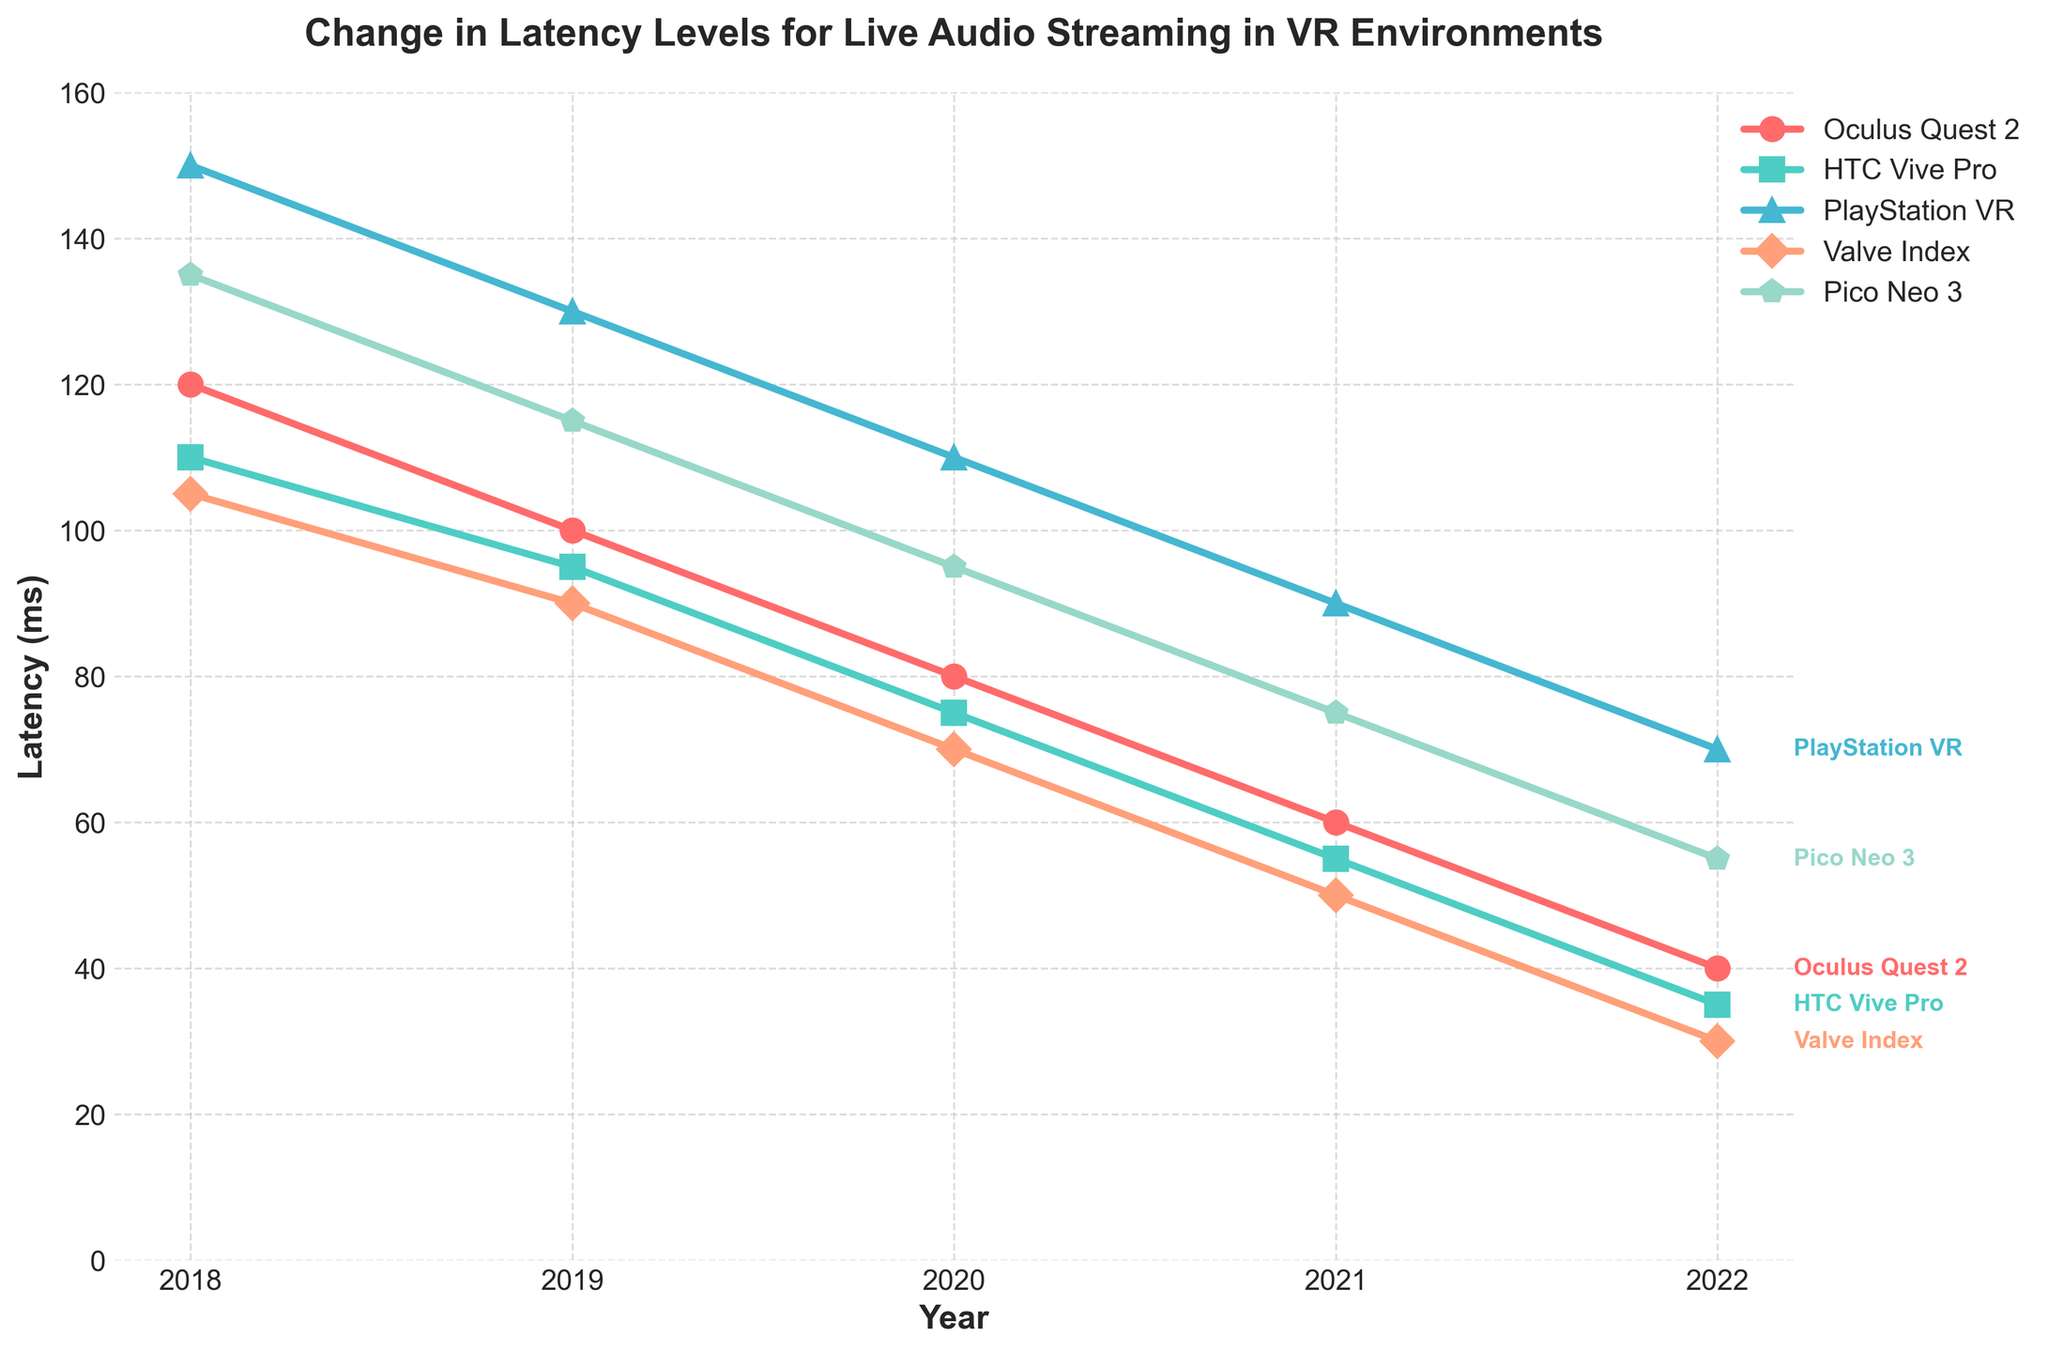What year did Oculus Quest 2 experience the most rapid drop in latency? In the figure, the latency for Oculus Quest 2 dropped by 20 ms each year from 2018 (120 ms) to 2022 (40 ms). However, the most rapid visual drop can be seen from 2018 to 2019, when it went from 120 ms to 100 ms.
Answer: 2018-2019 Which VR device had the lowest latency in 2022? According to the figure, in 2022, the latency for PlayStation VR was the lowest at 30 ms.
Answer: PlayStation VR By how much did the latency for HTC Vive Pro decrease from 2018 to 2022? From the figure, HTC Vive Pro decreased from 110 ms in 2018 to 35 ms in 2022. The difference is 110 - 35 = 75 ms.
Answer: 75 ms In 2019, which VR device had higher latency, Pico Neo 3 or Oculus Quest 2? In 2019, according to the figure, the latency for Pico Neo 3 was 115 ms, while for Oculus Quest 2 it was 100 ms. Pico Neo 3 had the higher latency.
Answer: Pico Neo 3 Calculate the average latency reduction per year across all devices from 2018 to 2022. For each device, the latency reduction from 2018 to 2022 is: 
Oculus Quest 2: 120 - 40 = 80 ms
HTC Vive Pro: 110 - 35 = 75 ms
PlayStation VR: 150 - 30 = 120 ms
Valve Index: 105 - 30 = 75 ms
Pico Neo 3: 135 - 55 = 80 ms
Then, average = (80 + 75 + 120 + 75 + 80) / 5 = 86 ms
Answer: 86 ms Which two devices had the same latency value at any point in the past five years? The figure shows that in 2019, both PlayStation VR and Pico Neo 3 had the same latency value of 130 ms.
Answer: PlayStation VR and Pico Neo 3 in 2019 How did the latency of Valve Index change between 2019 and 2021? According to the figure, the latency for Valve Index went from 90 ms in 2019 to 50 ms in 2021. The decrease is 90 - 50 = 40 ms.
Answer: Decreased by 40 ms Rank the devices by their latency improvements from greatest to least over the last five years. The total latency reduction from 2018 to 2022 for each device is: 
PlayStation VR: 120 ms (150 - 30)
Oculus Quest 2: 80 ms (120 - 40)
Pico Neo 3: 80 ms (135 - 55)
HTC Vive Pro: 75 ms (110 - 35)
Valve Index: 75 ms (105 - 30)
Therefore, the rank is:
1. PlayStation VR
2. Oculus Quest 2 / Pico Neo 3 (tie)
4. HTC Vive Pro / Valve Index (tie)
Answer: PlayStation VR, Oculus Quest 2/Pico Neo 3, HTC Vive Pro/Valve Index Which device exhibited the most consistent improvement in latency over the years? Analyzing the figure, the HTC Vive Pro shows a steady, almost linear decrease in latency each year, indicating the most consistent improvement.
Answer: HTC Vive Pro 